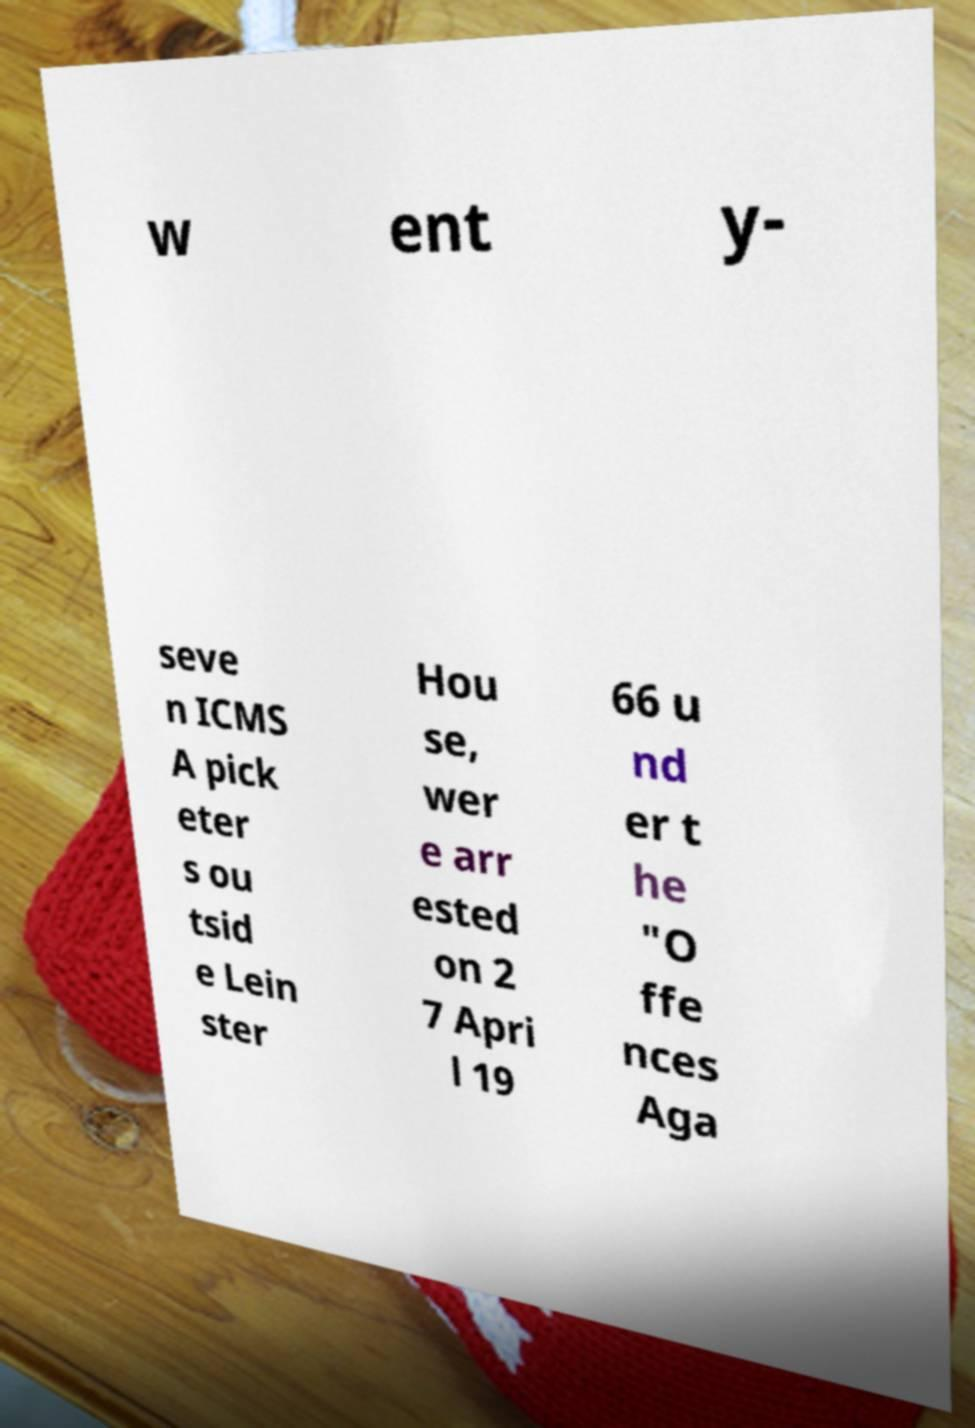Can you accurately transcribe the text from the provided image for me? w ent y- seve n ICMS A pick eter s ou tsid e Lein ster Hou se, wer e arr ested on 2 7 Apri l 19 66 u nd er t he "O ffe nces Aga 